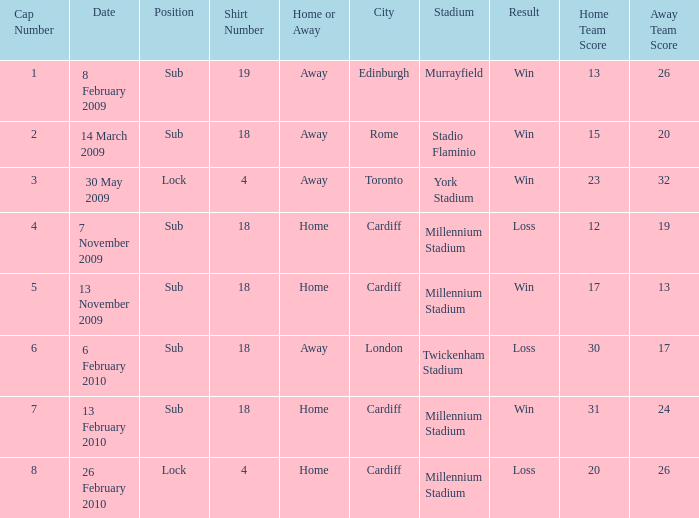Can you tell me the Score that has the Result of win, and the Date of 13 november 2009? 17–13. Could you parse the entire table as a dict? {'header': ['Cap Number', 'Date', 'Position', 'Shirt Number', 'Home or Away', 'City', 'Stadium', 'Result', 'Home Team Score', 'Away Team Score'], 'rows': [['1', '8 February 2009', 'Sub', '19', 'Away', 'Edinburgh', 'Murrayfield', 'Win', '13', '26'], ['2', '14 March 2009', 'Sub', '18', 'Away', 'Rome', 'Stadio Flaminio', 'Win', '15', '20'], ['3', '30 May 2009', 'Lock', '4', 'Away', 'Toronto', 'York Stadium', 'Win', '23', '32'], ['4', '7 November 2009', 'Sub', '18', 'Home', 'Cardiff', 'Millennium Stadium', 'Loss', '12', '19'], ['5', '13 November 2009', 'Sub', '18', 'Home', 'Cardiff', 'Millennium Stadium', 'Win', '17', '13'], ['6', '6 February 2010', 'Sub', '18', 'Away', 'London', 'Twickenham Stadium', 'Loss', '30', '17'], ['7', '13 February 2010', 'Sub', '18', 'Home', 'Cardiff', 'Millennium Stadium', 'Win', '31', '24'], ['8', '26 February 2010', 'Lock', '4', 'Home', 'Cardiff', 'Millennium Stadium', 'Loss', '20', '26']]} 